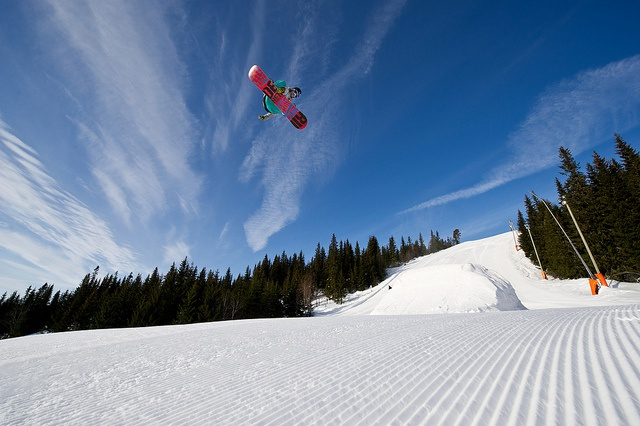Describe the objects in this image and their specific colors. I can see snowboard in blue, brown, and black tones and people in blue, black, teal, gray, and brown tones in this image. 